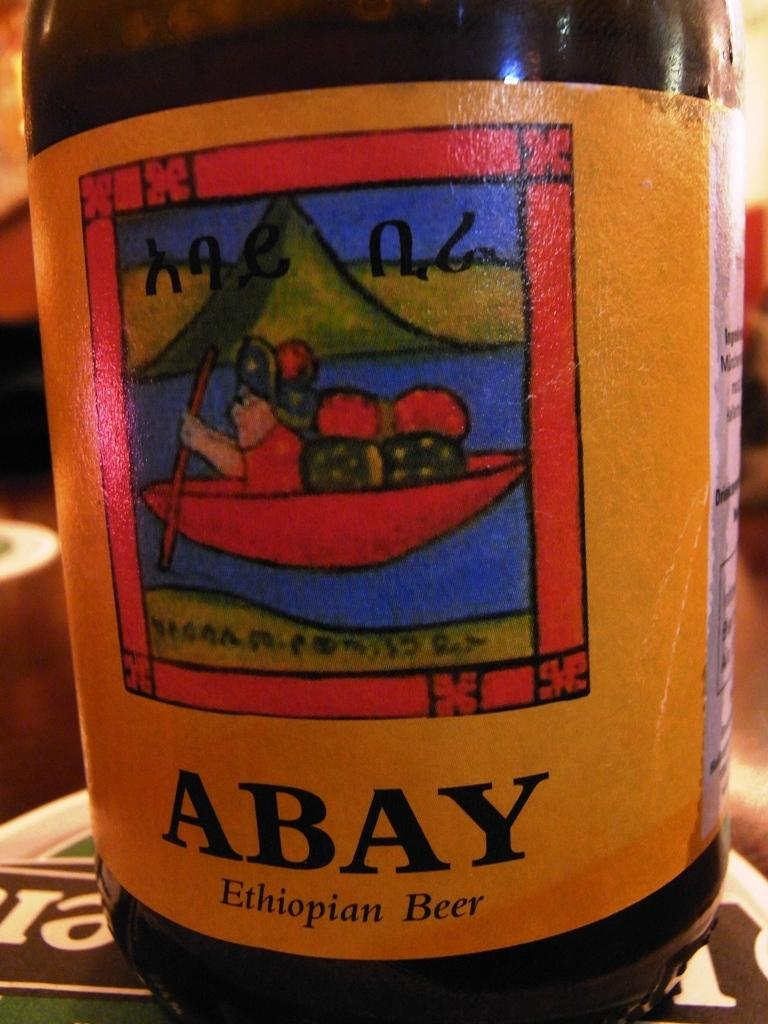<image>
Share a concise interpretation of the image provided. Abay Ethiopian beer bottle on top of a Heneiken sign. 